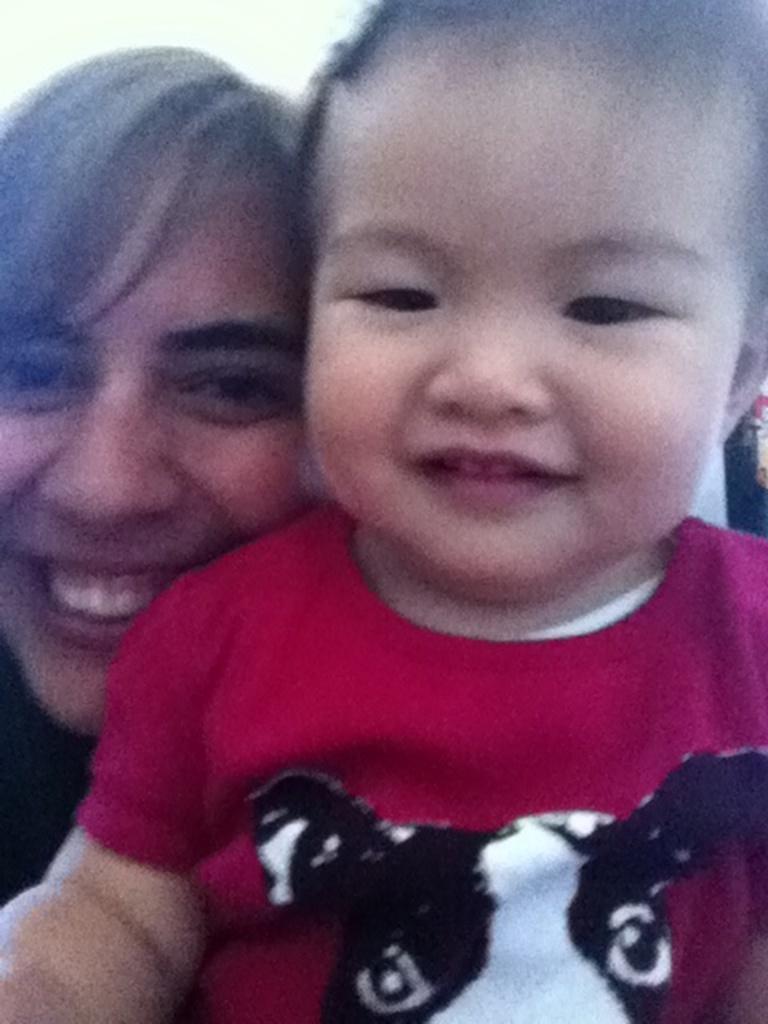How would you summarize this image in a sentence or two? In this image we can see a woman and a child are smiling. 